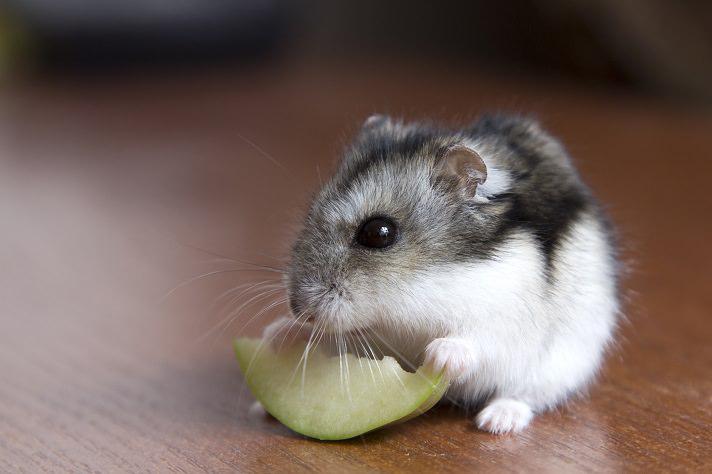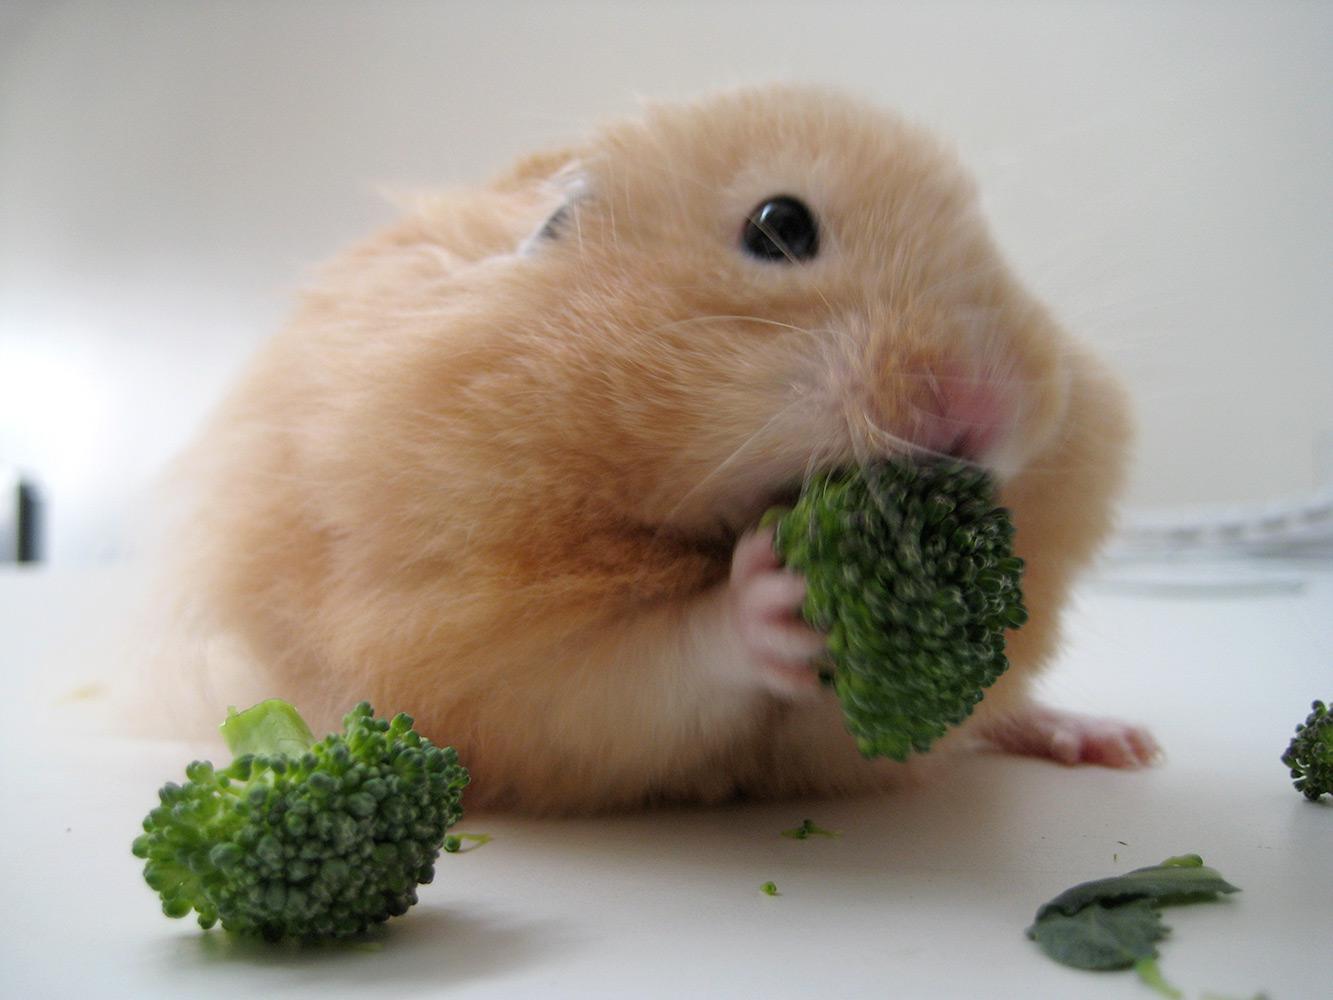The first image is the image on the left, the second image is the image on the right. Analyze the images presented: Is the assertion "A rodent is busy munching on a piece of broccoli." valid? Answer yes or no. Yes. The first image is the image on the left, the second image is the image on the right. Examine the images to the left and right. Is the description "A hamster is eating broccoli on a white floor" accurate? Answer yes or no. Yes. 